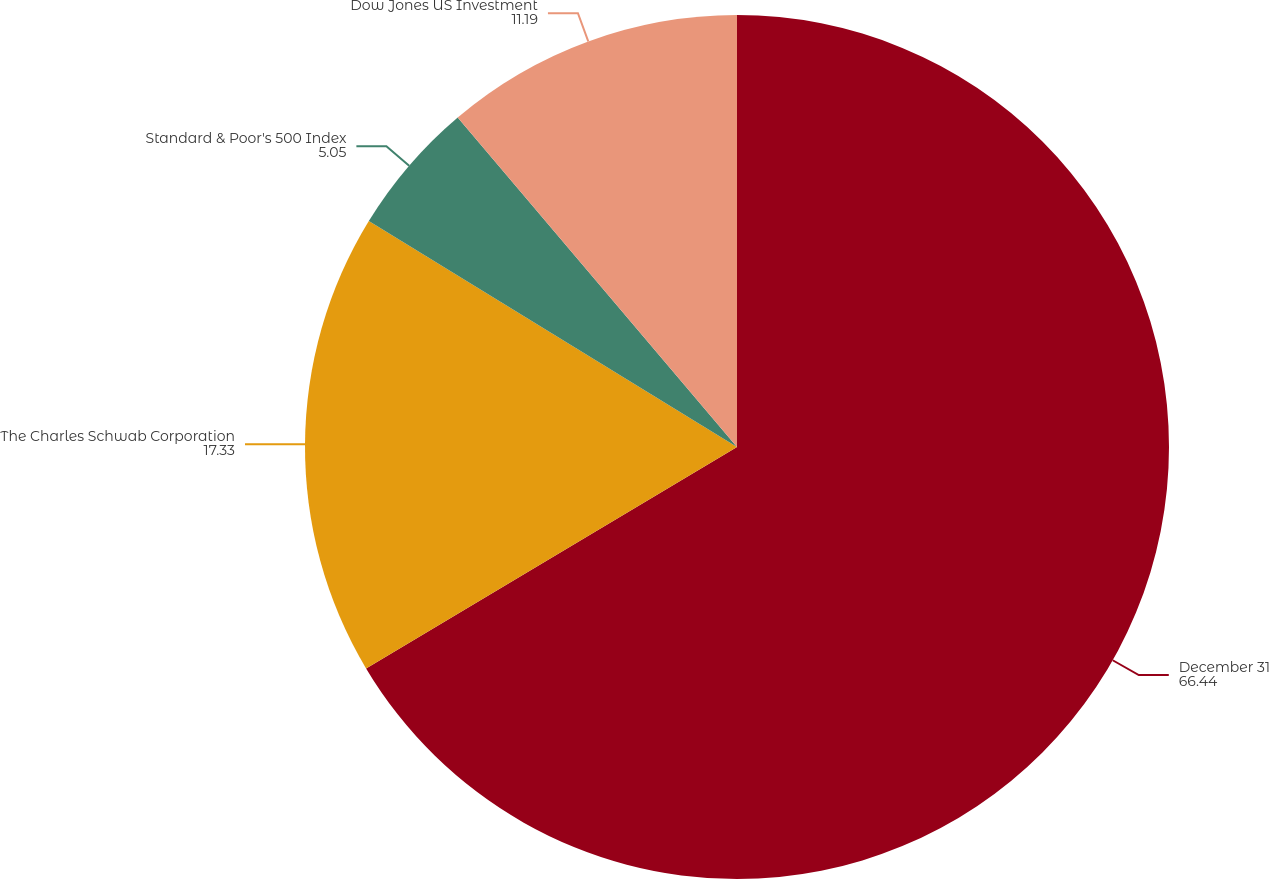Convert chart to OTSL. <chart><loc_0><loc_0><loc_500><loc_500><pie_chart><fcel>December 31<fcel>The Charles Schwab Corporation<fcel>Standard & Poor's 500 Index<fcel>Dow Jones US Investment<nl><fcel>66.44%<fcel>17.33%<fcel>5.05%<fcel>11.19%<nl></chart> 